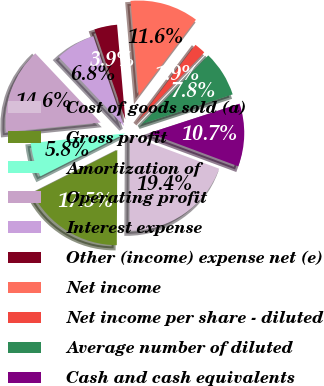<chart> <loc_0><loc_0><loc_500><loc_500><pie_chart><fcel>Cost of goods sold (a)<fcel>Gross profit<fcel>Amortization of<fcel>Operating profit<fcel>Interest expense<fcel>Other (income) expense net (e)<fcel>Net income<fcel>Net income per share - diluted<fcel>Average number of diluted<fcel>Cash and cash equivalents<nl><fcel>19.42%<fcel>17.48%<fcel>5.83%<fcel>14.56%<fcel>6.8%<fcel>3.88%<fcel>11.65%<fcel>1.94%<fcel>7.77%<fcel>10.68%<nl></chart> 